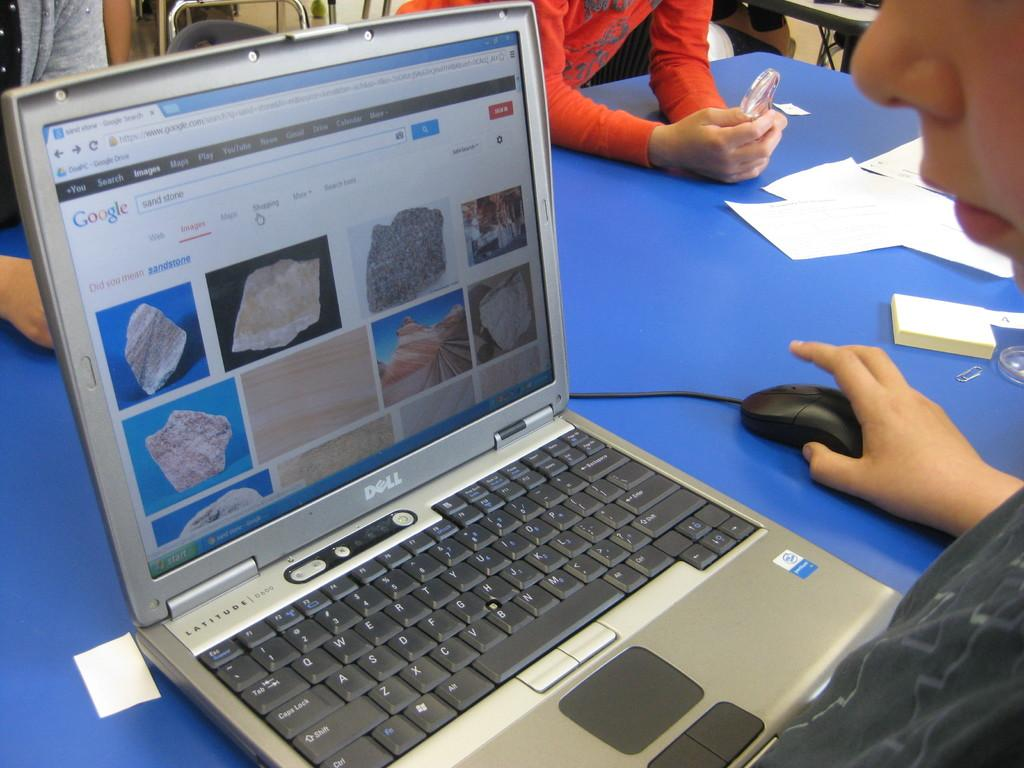<image>
Relay a brief, clear account of the picture shown. Someone sitting in front of a Dell laptop with different images of ricks shown on screen. 